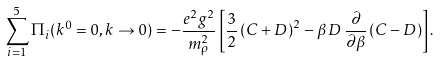<formula> <loc_0><loc_0><loc_500><loc_500>\sum _ { i = 1 } ^ { 5 } \Pi _ { i } ( k ^ { 0 } = 0 , { k } \to { 0 } ) = - \frac { e ^ { 2 } g ^ { 2 } } { m _ { \rho } ^ { 2 } } \left [ \frac { 3 } { 2 } \left ( C + D \right ) ^ { 2 } - \beta \, D \, \frac { \partial } { \partial \beta } \left ( C - D \right ) \right ] .</formula> 